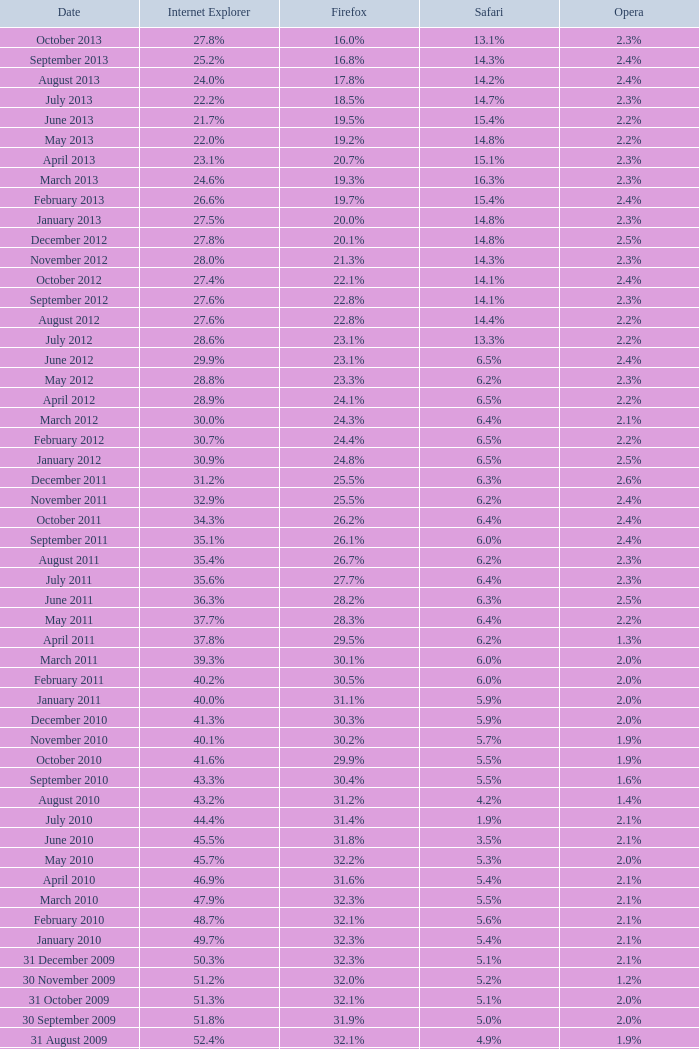What is the firefox value with a 22.0% internet explorer? 19.2%. 